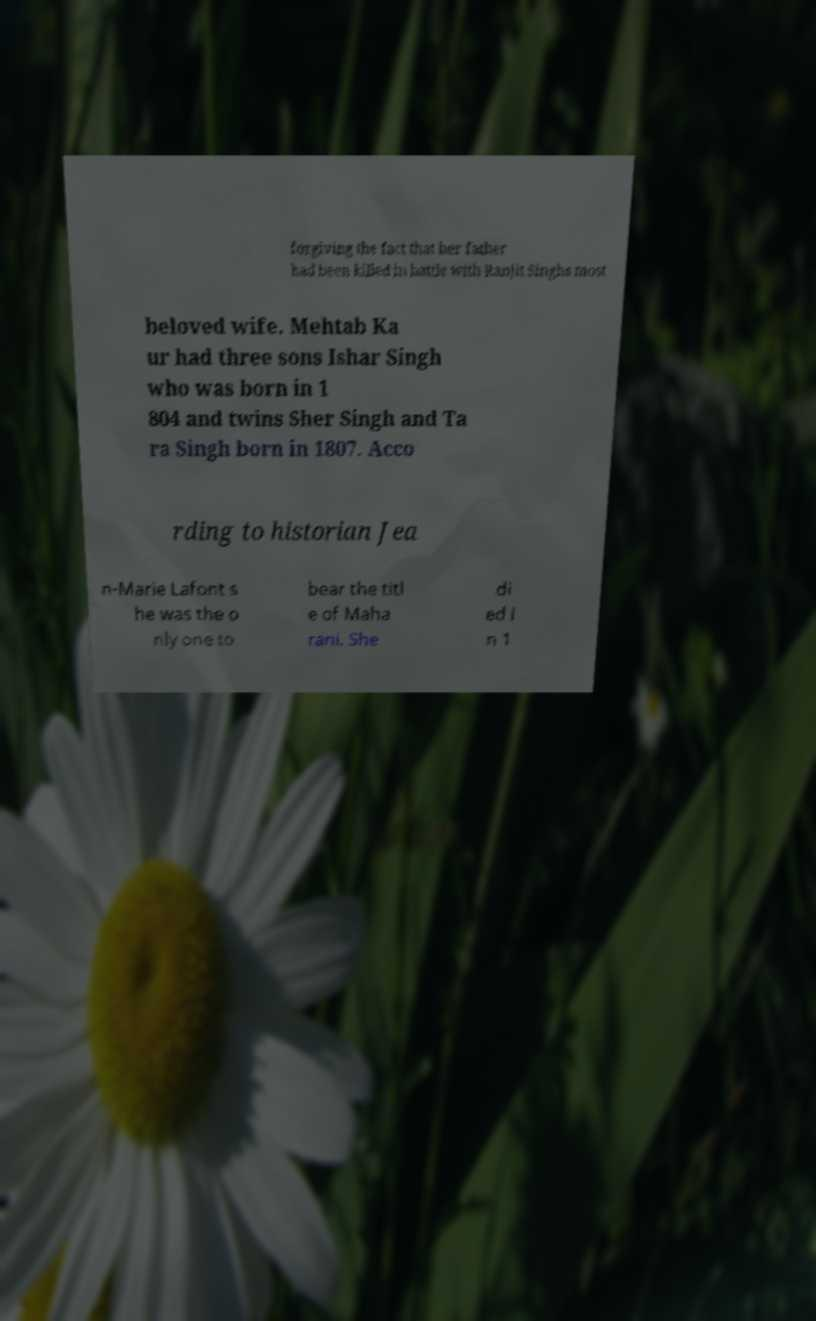Could you assist in decoding the text presented in this image and type it out clearly? forgiving the fact that her father had been killed in battle with Ranjit Singhs most beloved wife. Mehtab Ka ur had three sons Ishar Singh who was born in 1 804 and twins Sher Singh and Ta ra Singh born in 1807. Acco rding to historian Jea n-Marie Lafont s he was the o nly one to bear the titl e of Maha rani. She di ed i n 1 